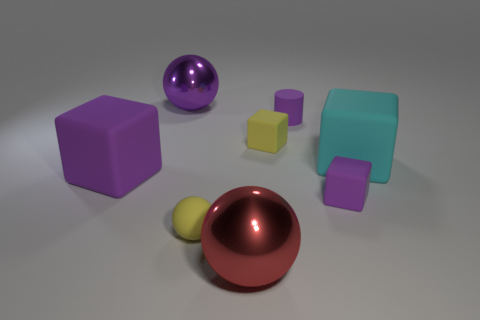Add 2 cyan things. How many objects exist? 10 Subtract all tiny yellow rubber blocks. How many blocks are left? 3 Subtract all brown balls. How many purple blocks are left? 2 Subtract 1 cubes. How many cubes are left? 3 Subtract all yellow cubes. How many cubes are left? 3 Subtract 0 brown cubes. How many objects are left? 8 Subtract all cylinders. How many objects are left? 7 Subtract all purple balls. Subtract all yellow cylinders. How many balls are left? 2 Subtract all small blue shiny blocks. Subtract all big purple shiny spheres. How many objects are left? 7 Add 2 large cyan cubes. How many large cyan cubes are left? 3 